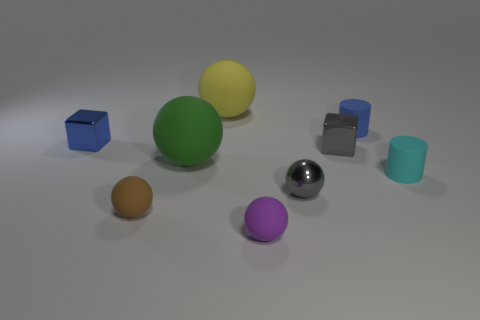How many tiny shiny objects are the same color as the small metal ball?
Your answer should be compact. 1. How many large things are blue rubber cylinders or cyan rubber cylinders?
Keep it short and to the point. 0. Are there any small red cylinders made of the same material as the small blue cube?
Keep it short and to the point. No. There is a block right of the big green sphere; what is it made of?
Give a very brief answer. Metal. There is a metallic cube that is to the left of the tiny brown sphere; does it have the same color as the tiny thing behind the blue cube?
Provide a succinct answer. Yes. There is a shiny sphere that is the same size as the cyan cylinder; what color is it?
Keep it short and to the point. Gray. What number of other things are the same shape as the large yellow object?
Offer a terse response. 4. What is the size of the blue cube on the left side of the small gray block?
Your answer should be compact. Small. How many rubber balls are to the right of the large thing that is behind the tiny gray metallic cube?
Give a very brief answer. 1. How many other objects are there of the same size as the brown rubber thing?
Your response must be concise. 6. 